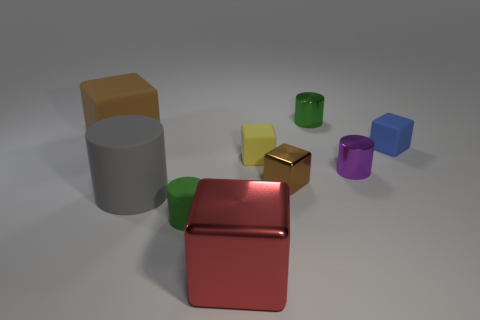There is a tiny thing that is the same color as the small matte cylinder; what shape is it?
Provide a succinct answer. Cylinder. Does the brown metal object have the same shape as the large brown thing?
Offer a terse response. Yes. How big is the green object left of the metallic thing in front of the green matte cylinder?
Offer a terse response. Small. Are there any brown blocks that have the same size as the yellow rubber cube?
Provide a short and direct response. Yes. There is a blue cube that is behind the large metal object; is it the same size as the green cylinder that is behind the gray thing?
Your answer should be very brief. Yes. What is the shape of the tiny rubber thing to the right of the cylinder that is behind the purple cylinder?
Your answer should be compact. Cube. There is a tiny green rubber thing; how many blue matte objects are in front of it?
Offer a terse response. 0. There is a big cylinder that is the same material as the yellow cube; what color is it?
Keep it short and to the point. Gray. There is a gray cylinder; does it have the same size as the green cylinder that is behind the brown shiny block?
Ensure brevity in your answer.  No. There is a rubber cylinder that is to the right of the matte cylinder that is to the left of the small rubber object that is on the left side of the big metallic cube; what is its size?
Your answer should be very brief. Small. 